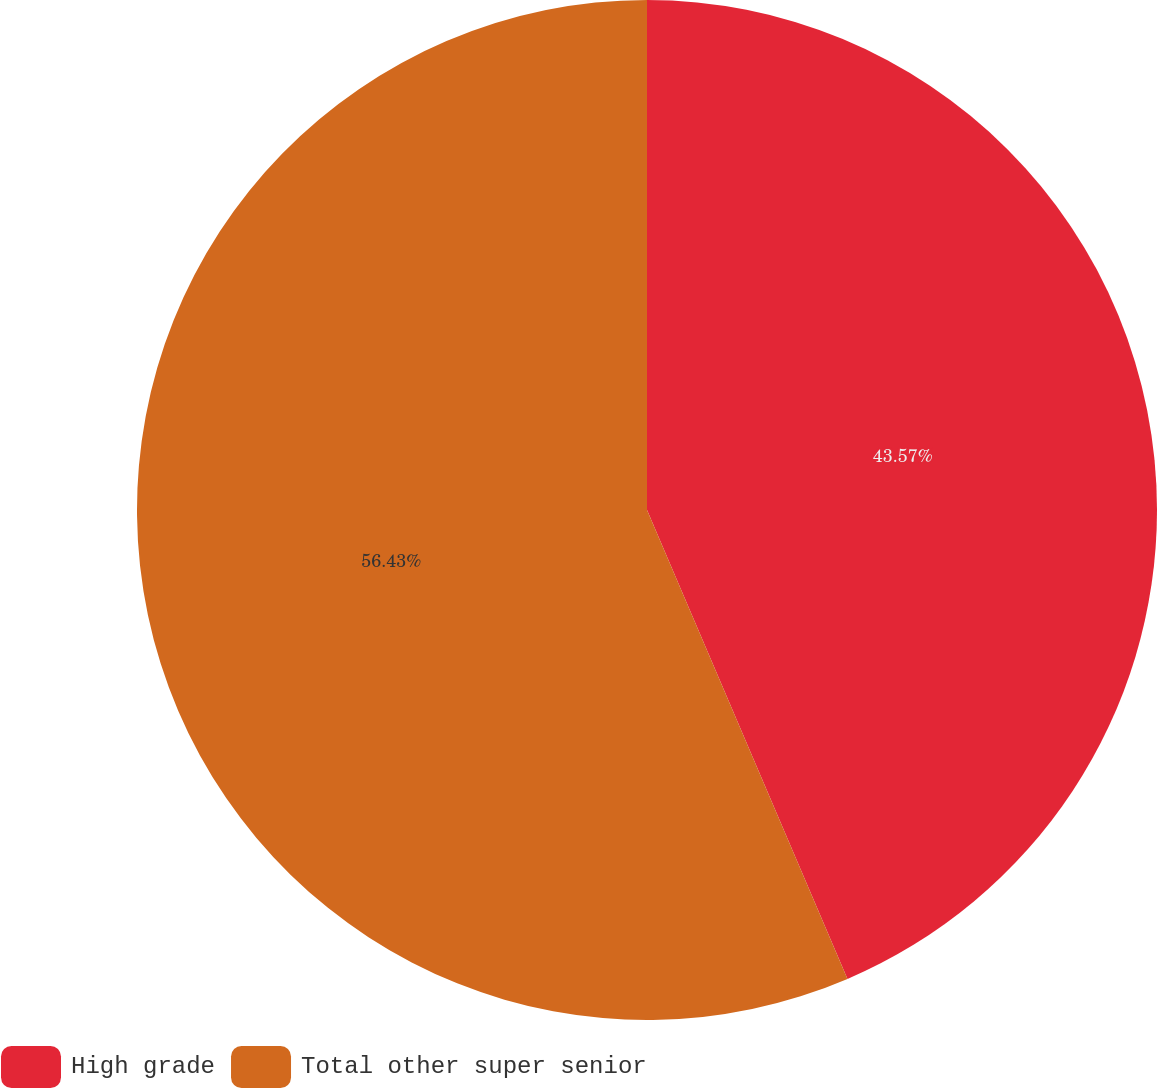<chart> <loc_0><loc_0><loc_500><loc_500><pie_chart><fcel>High grade<fcel>Total other super senior<nl><fcel>43.57%<fcel>56.43%<nl></chart> 